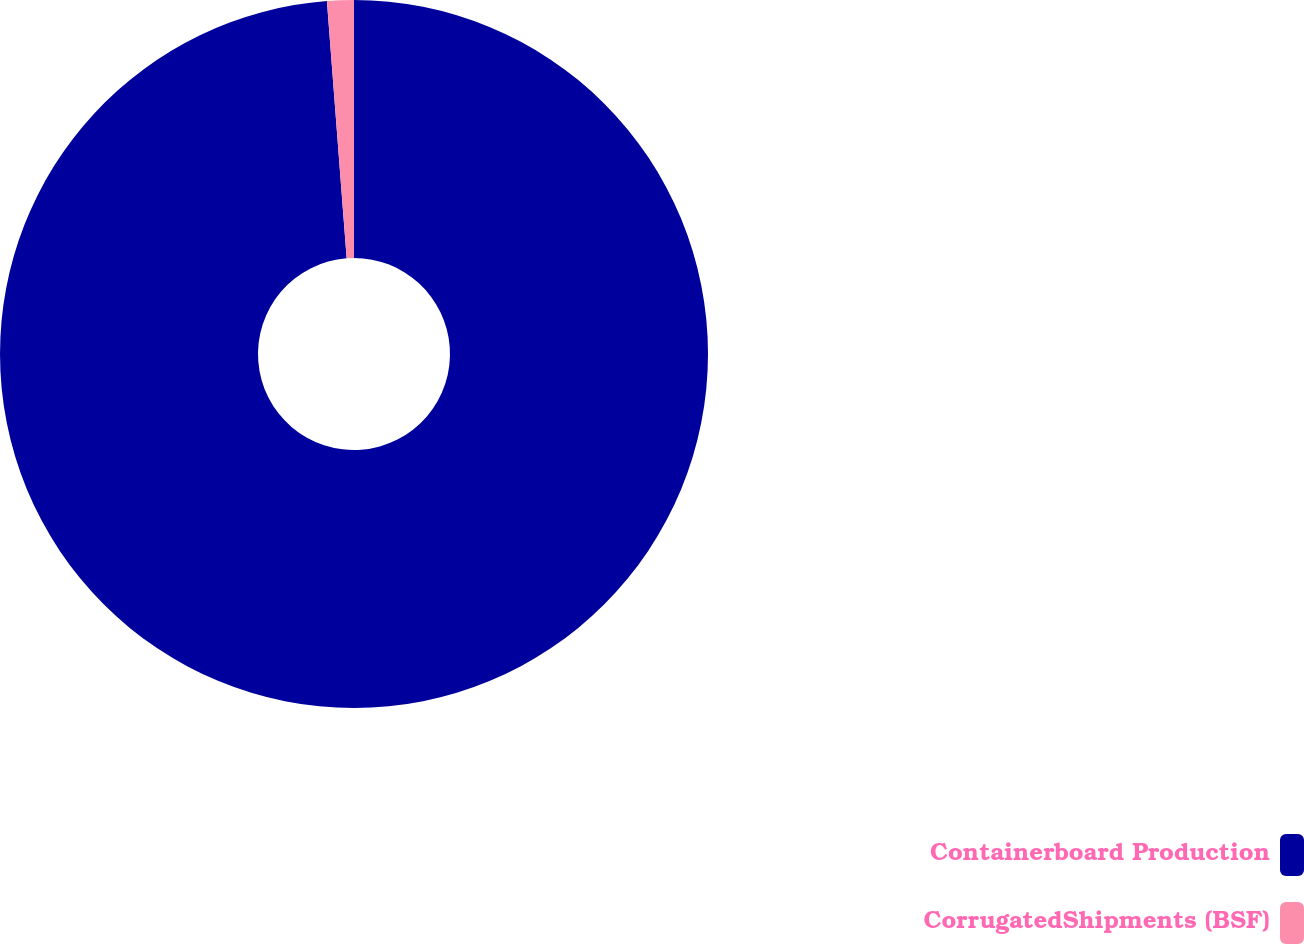Convert chart to OTSL. <chart><loc_0><loc_0><loc_500><loc_500><pie_chart><fcel>Containerboard Production<fcel>CorrugatedShipments (BSF)<nl><fcel>98.78%<fcel>1.22%<nl></chart> 